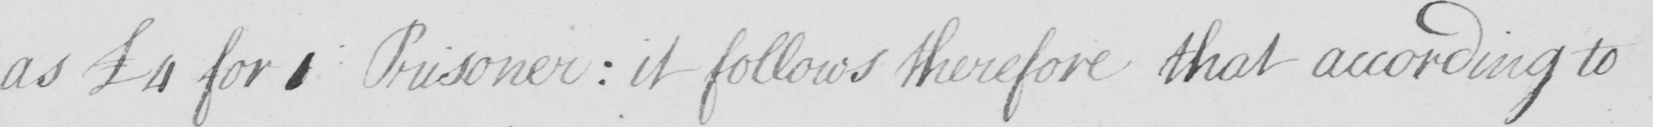What text is written in this handwritten line? as  £4 for 1 Prisoner :  it follows therefore that according to 